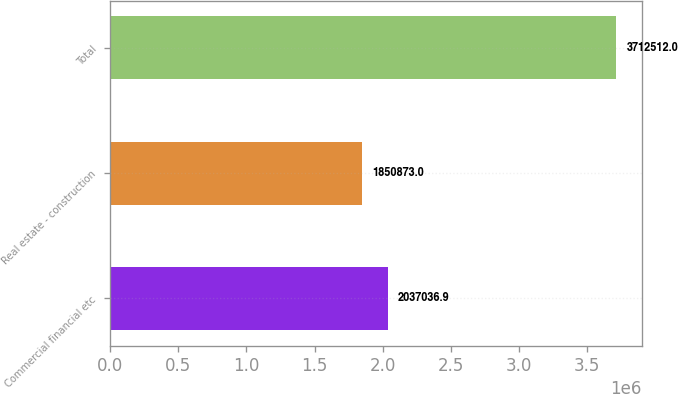Convert chart to OTSL. <chart><loc_0><loc_0><loc_500><loc_500><bar_chart><fcel>Commercial financial etc<fcel>Real estate - construction<fcel>Total<nl><fcel>2.03704e+06<fcel>1.85087e+06<fcel>3.71251e+06<nl></chart> 